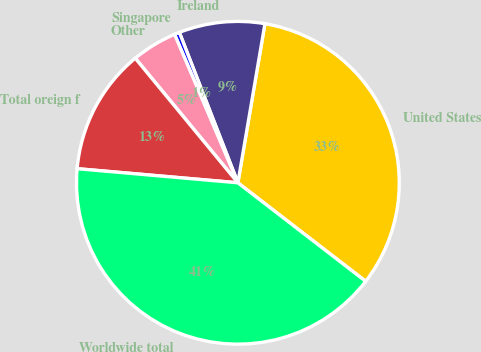Convert chart to OTSL. <chart><loc_0><loc_0><loc_500><loc_500><pie_chart><fcel>United States<fcel>Ireland<fcel>Singapore<fcel>Other<fcel>Total oreign f<fcel>Worldwide total<nl><fcel>32.77%<fcel>8.59%<fcel>0.51%<fcel>4.55%<fcel>12.64%<fcel>40.94%<nl></chart> 